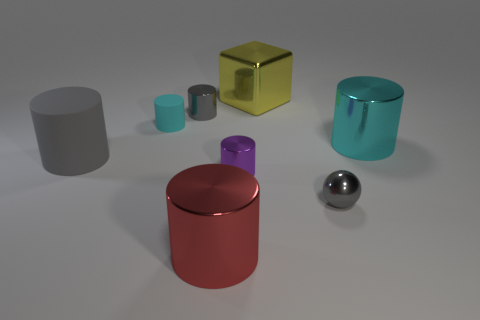Add 1 purple cubes. How many objects exist? 9 Subtract all small metal cylinders. How many cylinders are left? 4 Subtract all blocks. How many objects are left? 7 Subtract all purple cylinders. How many cylinders are left? 5 Add 6 balls. How many balls exist? 7 Subtract 0 red blocks. How many objects are left? 8 Subtract all blue cylinders. Subtract all blue blocks. How many cylinders are left? 6 Subtract all blue cylinders. How many yellow balls are left? 0 Subtract all cyan rubber cylinders. Subtract all red metal blocks. How many objects are left? 7 Add 2 big metal blocks. How many big metal blocks are left? 3 